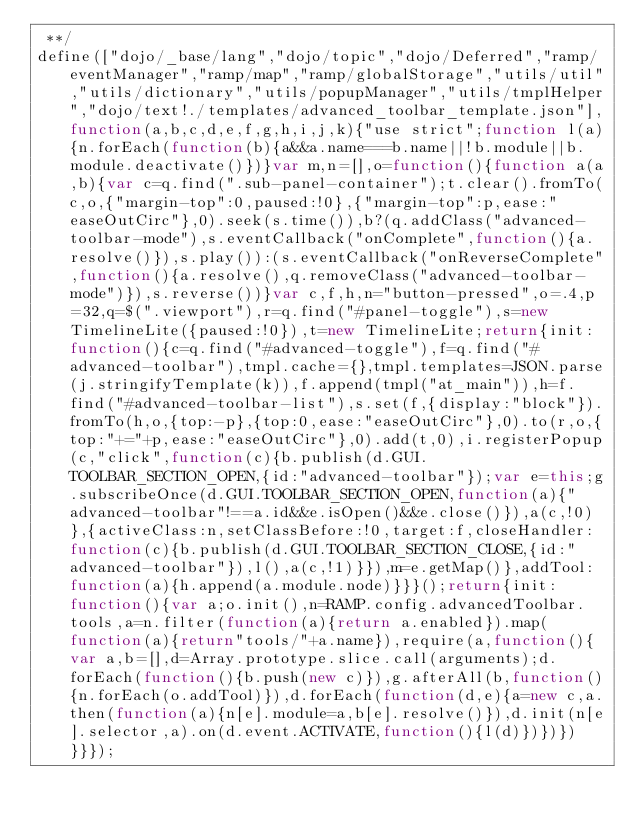<code> <loc_0><loc_0><loc_500><loc_500><_JavaScript_> **/
define(["dojo/_base/lang","dojo/topic","dojo/Deferred","ramp/eventManager","ramp/map","ramp/globalStorage","utils/util","utils/dictionary","utils/popupManager","utils/tmplHelper","dojo/text!./templates/advanced_toolbar_template.json"],function(a,b,c,d,e,f,g,h,i,j,k){"use strict";function l(a){n.forEach(function(b){a&&a.name===b.name||!b.module||b.module.deactivate()})}var m,n=[],o=function(){function a(a,b){var c=q.find(".sub-panel-container");t.clear().fromTo(c,o,{"margin-top":0,paused:!0},{"margin-top":p,ease:"easeOutCirc"},0).seek(s.time()),b?(q.addClass("advanced-toolbar-mode"),s.eventCallback("onComplete",function(){a.resolve()}),s.play()):(s.eventCallback("onReverseComplete",function(){a.resolve(),q.removeClass("advanced-toolbar-mode")}),s.reverse())}var c,f,h,n="button-pressed",o=.4,p=32,q=$(".viewport"),r=q.find("#panel-toggle"),s=new TimelineLite({paused:!0}),t=new TimelineLite;return{init:function(){c=q.find("#advanced-toggle"),f=q.find("#advanced-toolbar"),tmpl.cache={},tmpl.templates=JSON.parse(j.stringifyTemplate(k)),f.append(tmpl("at_main")),h=f.find("#advanced-toolbar-list"),s.set(f,{display:"block"}).fromTo(h,o,{top:-p},{top:0,ease:"easeOutCirc"},0).to(r,o,{top:"+="+p,ease:"easeOutCirc"},0).add(t,0),i.registerPopup(c,"click",function(c){b.publish(d.GUI.TOOLBAR_SECTION_OPEN,{id:"advanced-toolbar"});var e=this;g.subscribeOnce(d.GUI.TOOLBAR_SECTION_OPEN,function(a){"advanced-toolbar"!==a.id&&e.isOpen()&&e.close()}),a(c,!0)},{activeClass:n,setClassBefore:!0,target:f,closeHandler:function(c){b.publish(d.GUI.TOOLBAR_SECTION_CLOSE,{id:"advanced-toolbar"}),l(),a(c,!1)}}),m=e.getMap()},addTool:function(a){h.append(a.module.node)}}}();return{init:function(){var a;o.init(),n=RAMP.config.advancedToolbar.tools,a=n.filter(function(a){return a.enabled}).map(function(a){return"tools/"+a.name}),require(a,function(){var a,b=[],d=Array.prototype.slice.call(arguments);d.forEach(function(){b.push(new c)}),g.afterAll(b,function(){n.forEach(o.addTool)}),d.forEach(function(d,e){a=new c,a.then(function(a){n[e].module=a,b[e].resolve()}),d.init(n[e].selector,a).on(d.event.ACTIVATE,function(){l(d)})})})}}});</code> 